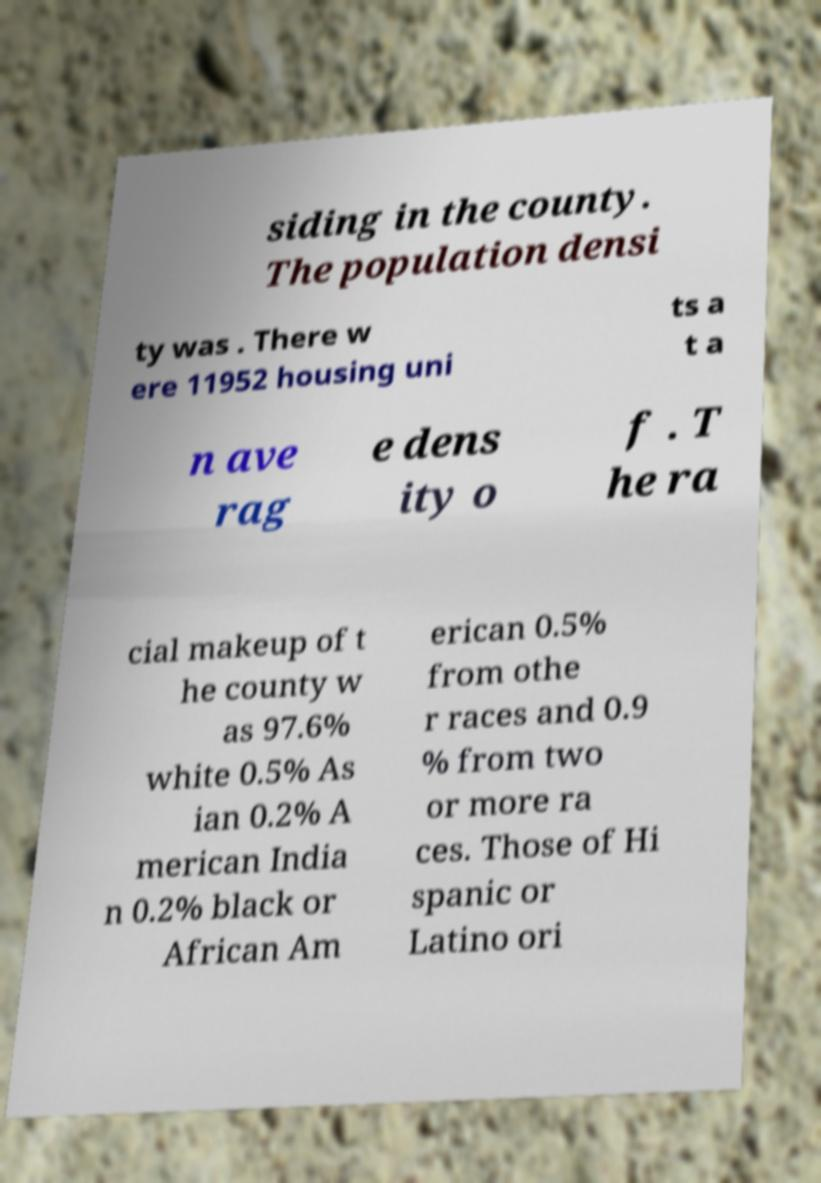Could you assist in decoding the text presented in this image and type it out clearly? siding in the county. The population densi ty was . There w ere 11952 housing uni ts a t a n ave rag e dens ity o f . T he ra cial makeup of t he county w as 97.6% white 0.5% As ian 0.2% A merican India n 0.2% black or African Am erican 0.5% from othe r races and 0.9 % from two or more ra ces. Those of Hi spanic or Latino ori 